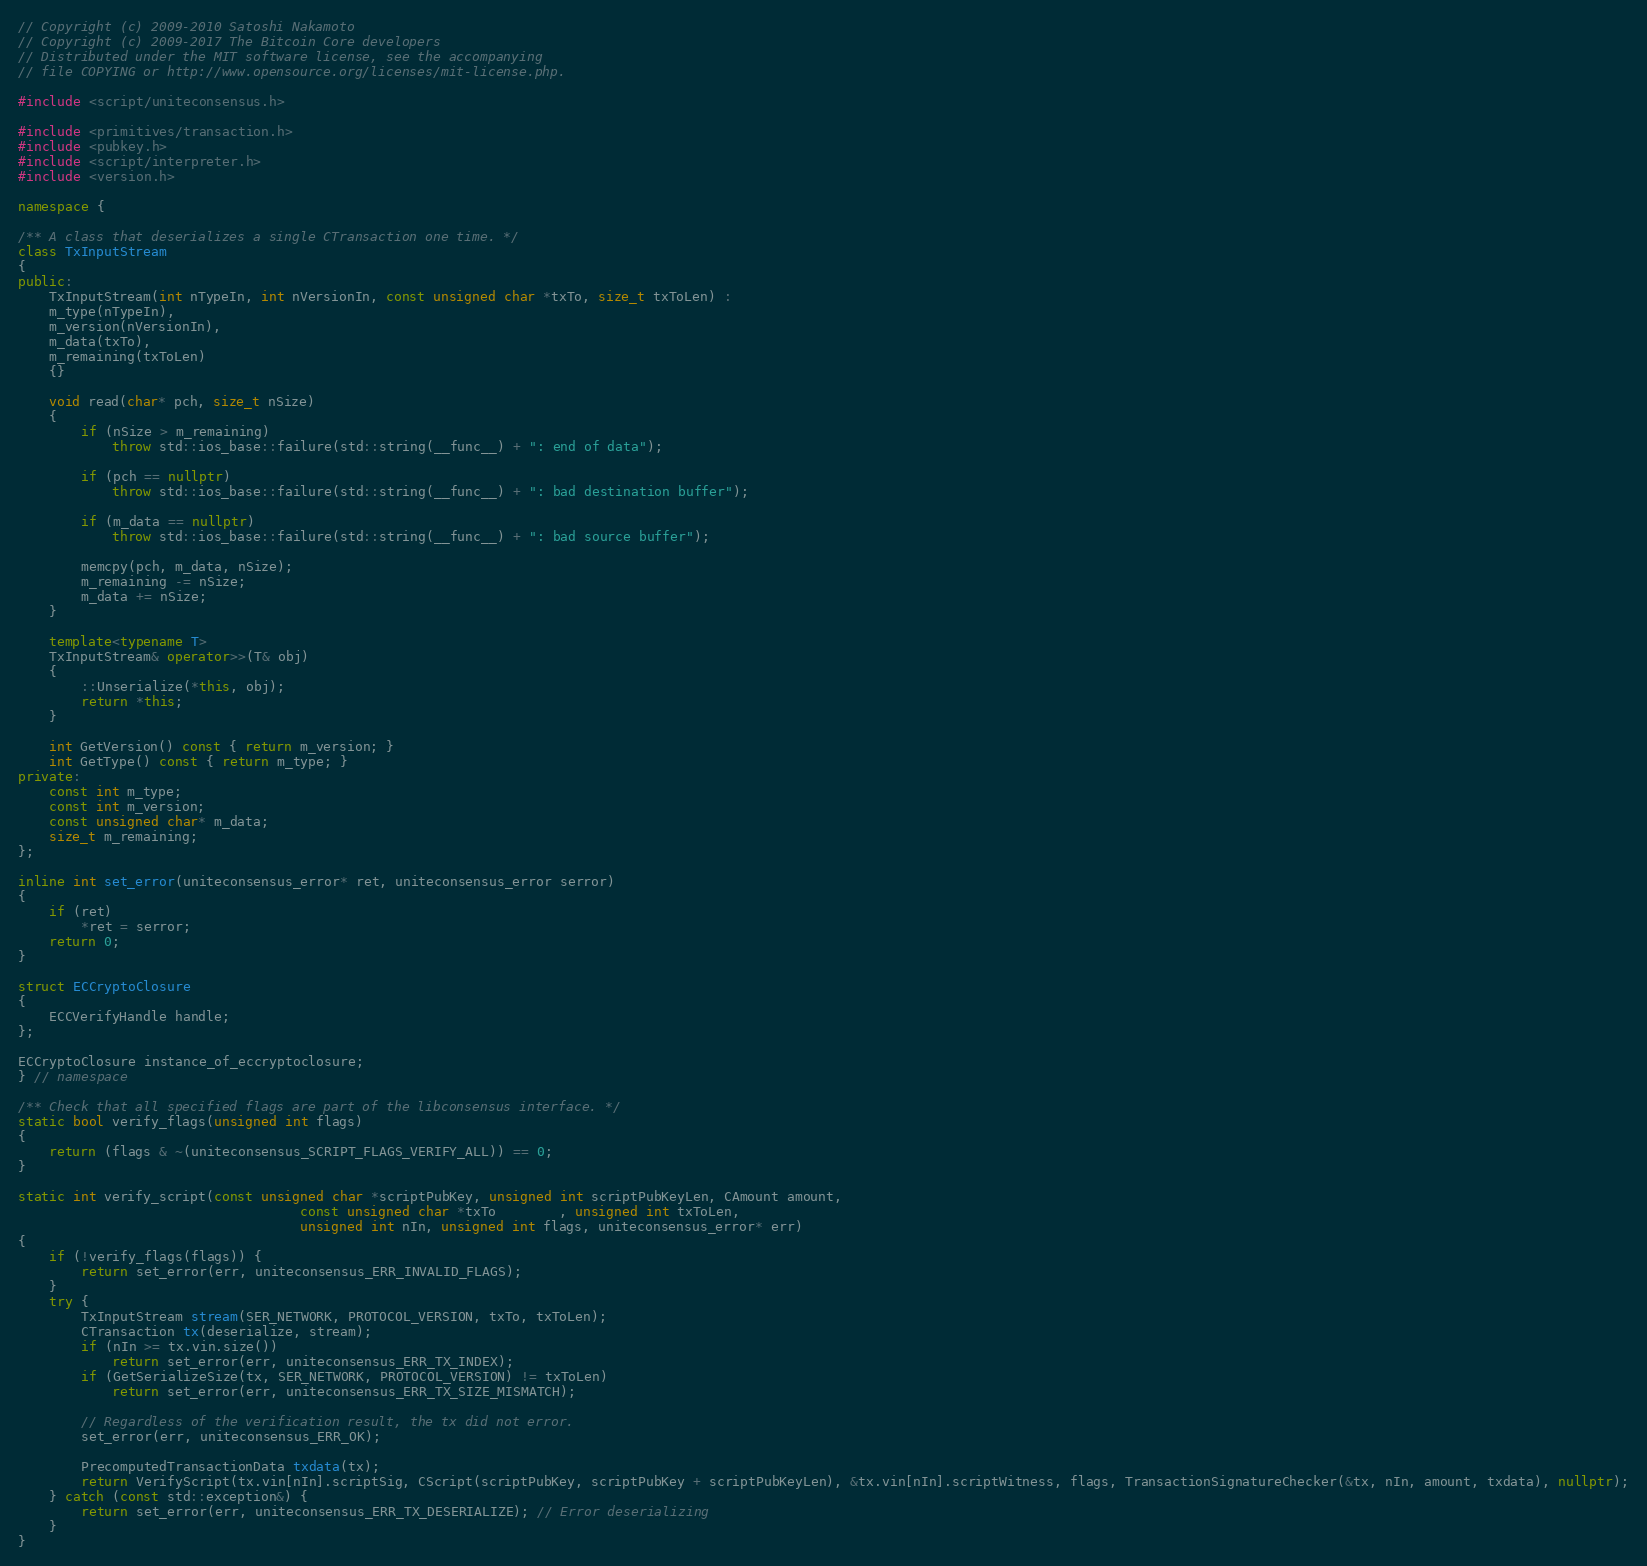Convert code to text. <code><loc_0><loc_0><loc_500><loc_500><_C++_>// Copyright (c) 2009-2010 Satoshi Nakamoto
// Copyright (c) 2009-2017 The Bitcoin Core developers
// Distributed under the MIT software license, see the accompanying
// file COPYING or http://www.opensource.org/licenses/mit-license.php.

#include <script/uniteconsensus.h>

#include <primitives/transaction.h>
#include <pubkey.h>
#include <script/interpreter.h>
#include <version.h>

namespace {

/** A class that deserializes a single CTransaction one time. */
class TxInputStream
{
public:
    TxInputStream(int nTypeIn, int nVersionIn, const unsigned char *txTo, size_t txToLen) :
    m_type(nTypeIn),
    m_version(nVersionIn),
    m_data(txTo),
    m_remaining(txToLen)
    {}

    void read(char* pch, size_t nSize)
    {
        if (nSize > m_remaining)
            throw std::ios_base::failure(std::string(__func__) + ": end of data");

        if (pch == nullptr)
            throw std::ios_base::failure(std::string(__func__) + ": bad destination buffer");

        if (m_data == nullptr)
            throw std::ios_base::failure(std::string(__func__) + ": bad source buffer");

        memcpy(pch, m_data, nSize);
        m_remaining -= nSize;
        m_data += nSize;
    }

    template<typename T>
    TxInputStream& operator>>(T& obj)
    {
        ::Unserialize(*this, obj);
        return *this;
    }

    int GetVersion() const { return m_version; }
    int GetType() const { return m_type; }
private:
    const int m_type;
    const int m_version;
    const unsigned char* m_data;
    size_t m_remaining;
};

inline int set_error(uniteconsensus_error* ret, uniteconsensus_error serror)
{
    if (ret)
        *ret = serror;
    return 0;
}

struct ECCryptoClosure
{
    ECCVerifyHandle handle;
};

ECCryptoClosure instance_of_eccryptoclosure;
} // namespace

/** Check that all specified flags are part of the libconsensus interface. */
static bool verify_flags(unsigned int flags)
{
    return (flags & ~(uniteconsensus_SCRIPT_FLAGS_VERIFY_ALL)) == 0;
}

static int verify_script(const unsigned char *scriptPubKey, unsigned int scriptPubKeyLen, CAmount amount,
                                    const unsigned char *txTo        , unsigned int txToLen,
                                    unsigned int nIn, unsigned int flags, uniteconsensus_error* err)
{
    if (!verify_flags(flags)) {
        return set_error(err, uniteconsensus_ERR_INVALID_FLAGS);
    }
    try {
        TxInputStream stream(SER_NETWORK, PROTOCOL_VERSION, txTo, txToLen);
        CTransaction tx(deserialize, stream);
        if (nIn >= tx.vin.size())
            return set_error(err, uniteconsensus_ERR_TX_INDEX);
        if (GetSerializeSize(tx, SER_NETWORK, PROTOCOL_VERSION) != txToLen)
            return set_error(err, uniteconsensus_ERR_TX_SIZE_MISMATCH);

        // Regardless of the verification result, the tx did not error.
        set_error(err, uniteconsensus_ERR_OK);

        PrecomputedTransactionData txdata(tx);
        return VerifyScript(tx.vin[nIn].scriptSig, CScript(scriptPubKey, scriptPubKey + scriptPubKeyLen), &tx.vin[nIn].scriptWitness, flags, TransactionSignatureChecker(&tx, nIn, amount, txdata), nullptr);
    } catch (const std::exception&) {
        return set_error(err, uniteconsensus_ERR_TX_DESERIALIZE); // Error deserializing
    }
}
</code> 